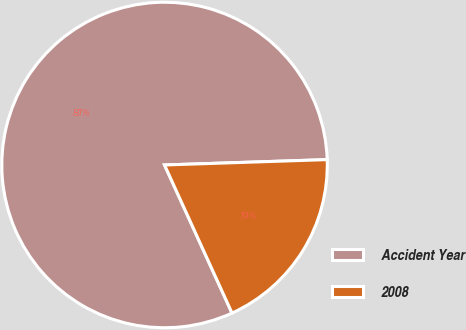<chart> <loc_0><loc_0><loc_500><loc_500><pie_chart><fcel>Accident Year<fcel>2008<nl><fcel>81.28%<fcel>18.72%<nl></chart> 